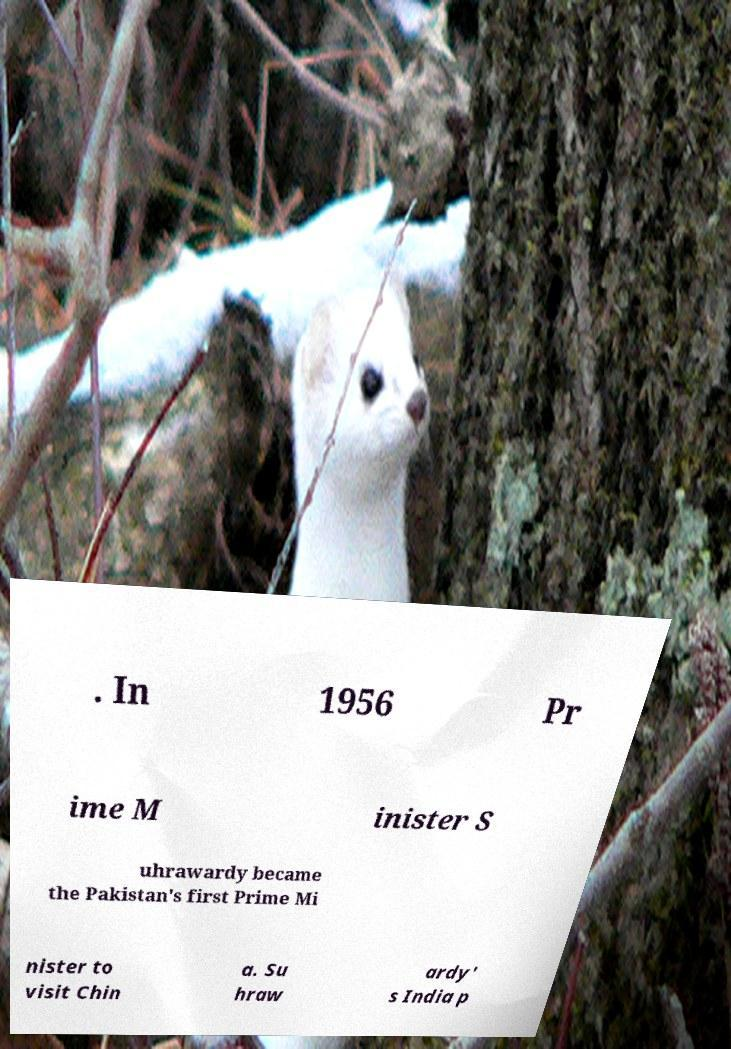What messages or text are displayed in this image? I need them in a readable, typed format. . In 1956 Pr ime M inister S uhrawardy became the Pakistan's first Prime Mi nister to visit Chin a. Su hraw ardy' s India p 